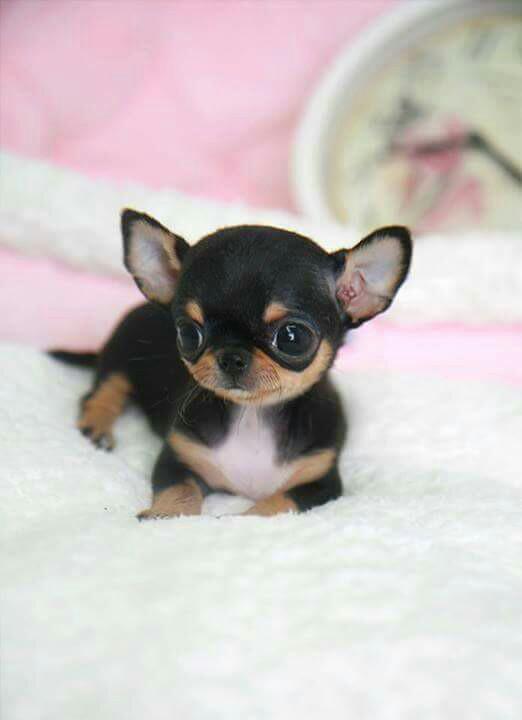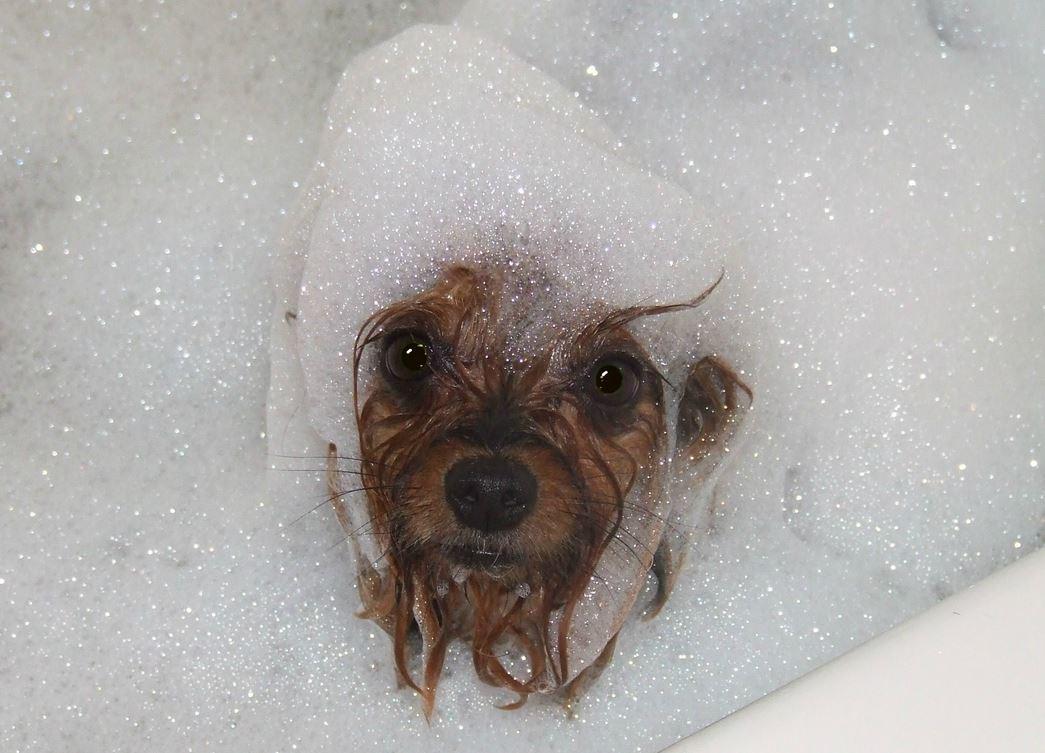The first image is the image on the left, the second image is the image on the right. Assess this claim about the two images: "Both images show a small dog in contact with water.". Correct or not? Answer yes or no. No. The first image is the image on the left, the second image is the image on the right. Considering the images on both sides, is "One of the images shows a dog with bubbles on top of its head." valid? Answer yes or no. Yes. 